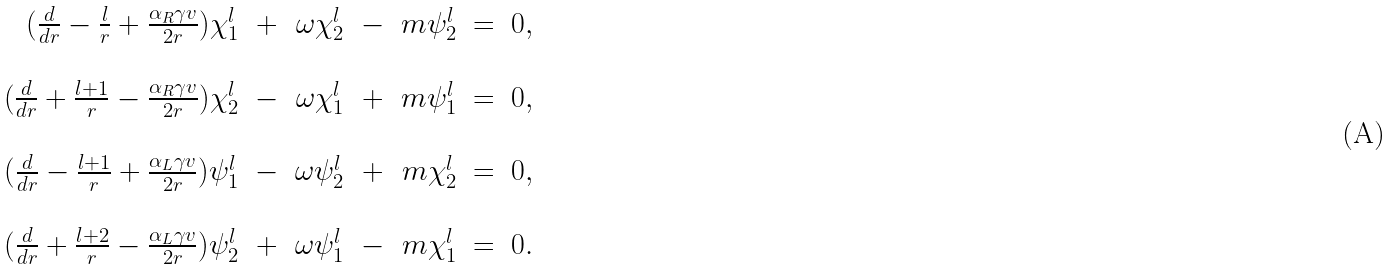<formula> <loc_0><loc_0><loc_500><loc_500>\begin{array} { r c r c r c l } ( \frac { d } { d r } - \frac { l } { r } + \frac { \alpha _ { R } \gamma v } { 2 r } ) \chi ^ { l } _ { 1 } & + & \omega \chi ^ { l } _ { 2 } & - & m \psi _ { 2 } ^ { l } & = & 0 , \\ & & & & & & \\ ( \frac { d } { d r } + \frac { l + 1 } { r } - \frac { \alpha _ { R } \gamma v } { 2 r } ) \chi ^ { l } _ { 2 } & - & \omega \chi ^ { l } _ { 1 } & + & m \psi _ { 1 } ^ { l } & = & 0 , \\ & & & & & & \\ ( \frac { d } { d r } - \frac { l + 1 } { r } + \frac { \alpha _ { L } \gamma v } { 2 r } ) \psi ^ { l } _ { 1 } & - & \omega \psi ^ { l } _ { 2 } & + & m \chi _ { 2 } ^ { l } & = & 0 , \\ & & & & & & \\ ( \frac { d } { d r } + \frac { l + 2 } { r } - \frac { \alpha _ { L } \gamma v } { 2 r } ) \psi ^ { l } _ { 2 } & + & \omega \psi ^ { l } _ { 1 } & - & m \chi _ { 1 } ^ { l } & = & 0 . \\ \end{array}</formula> 